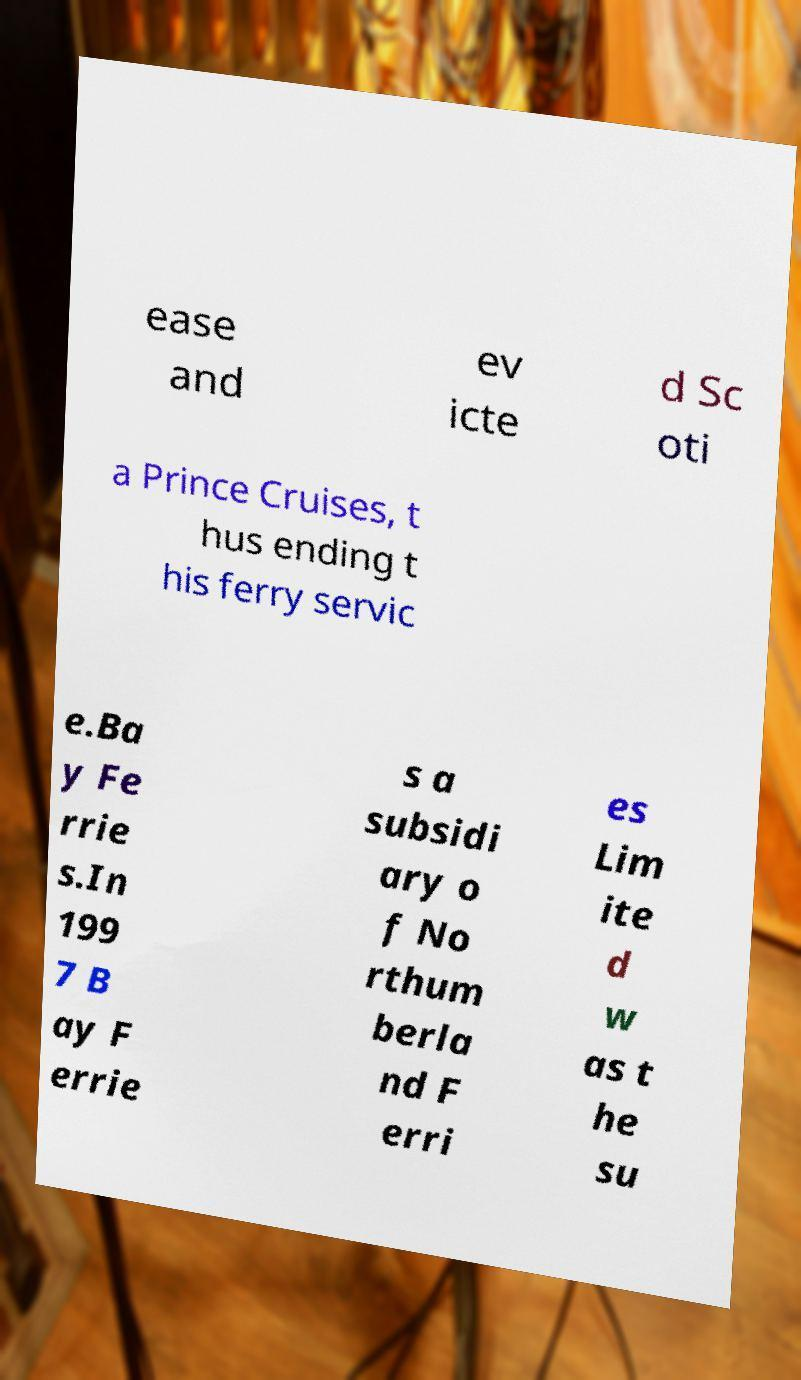Could you extract and type out the text from this image? ease and ev icte d Sc oti a Prince Cruises, t hus ending t his ferry servic e.Ba y Fe rrie s.In 199 7 B ay F errie s a subsidi ary o f No rthum berla nd F erri es Lim ite d w as t he su 